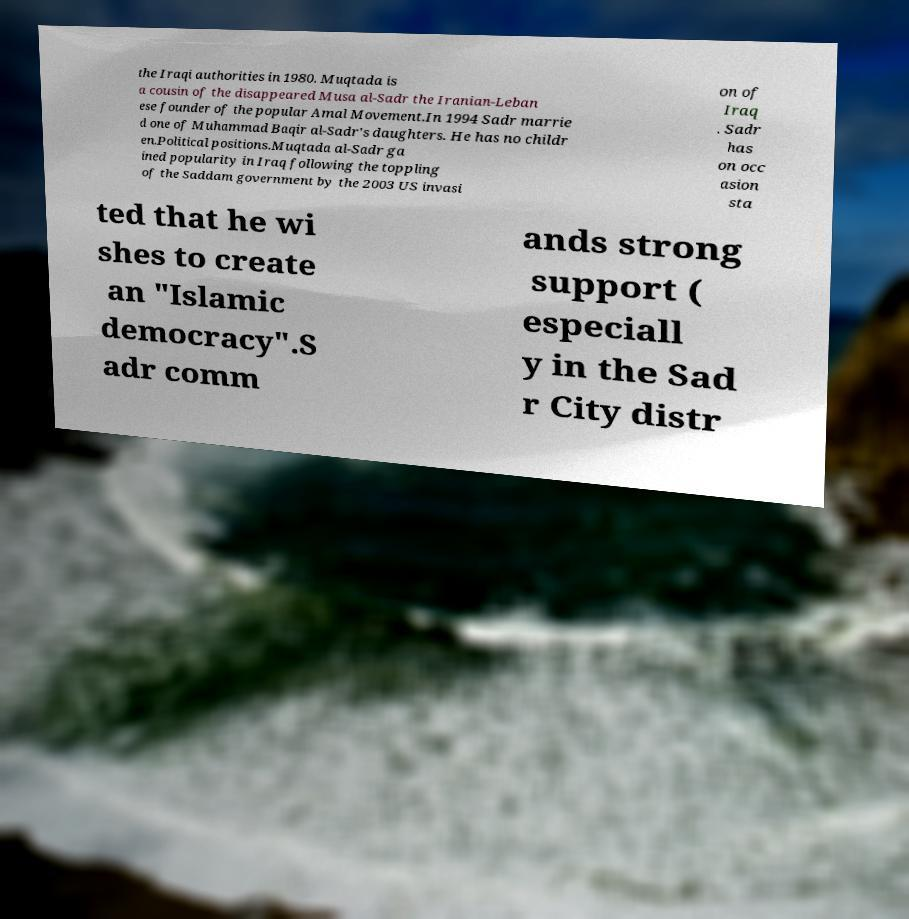Could you extract and type out the text from this image? the Iraqi authorities in 1980. Muqtada is a cousin of the disappeared Musa al-Sadr the Iranian-Leban ese founder of the popular Amal Movement.In 1994 Sadr marrie d one of Muhammad Baqir al-Sadr's daughters. He has no childr en.Political positions.Muqtada al-Sadr ga ined popularity in Iraq following the toppling of the Saddam government by the 2003 US invasi on of Iraq . Sadr has on occ asion sta ted that he wi shes to create an "Islamic democracy".S adr comm ands strong support ( especiall y in the Sad r City distr 